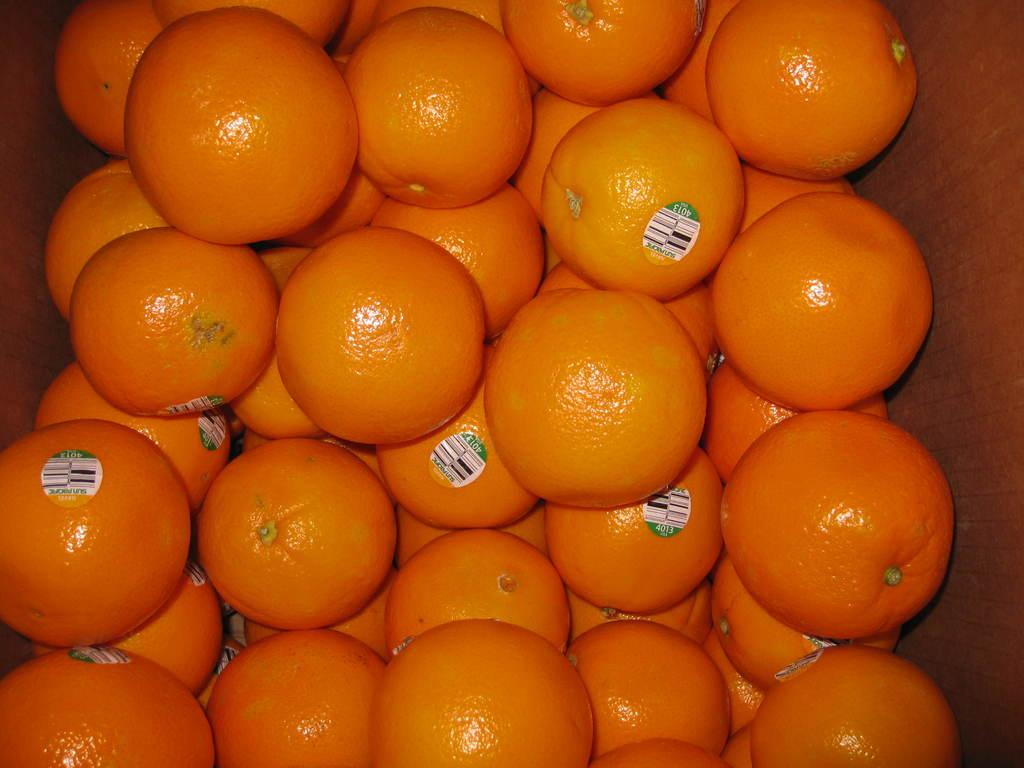What type of fruit is present in the image? There are oranges in the image. How are the oranges stored or contained in the image? The oranges are kept in a box. How many horses does the owner of the oranges have in the image? There is no information about an owner or horses in the image; it only shows oranges in a box. 